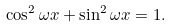Convert formula to latex. <formula><loc_0><loc_0><loc_500><loc_500>\cos ^ { 2 } \omega x + \sin ^ { 2 } \omega x = 1 .</formula> 